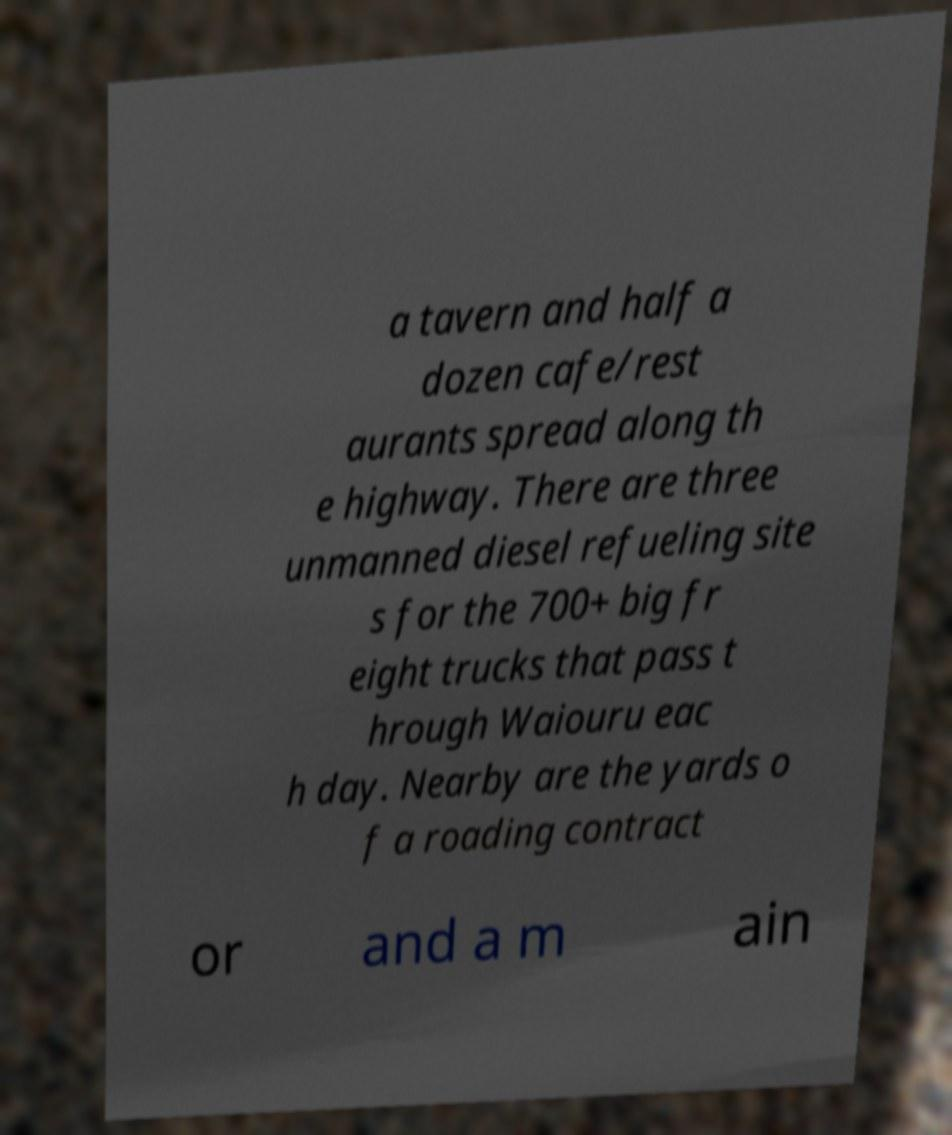Please read and relay the text visible in this image. What does it say? a tavern and half a dozen cafe/rest aurants spread along th e highway. There are three unmanned diesel refueling site s for the 700+ big fr eight trucks that pass t hrough Waiouru eac h day. Nearby are the yards o f a roading contract or and a m ain 